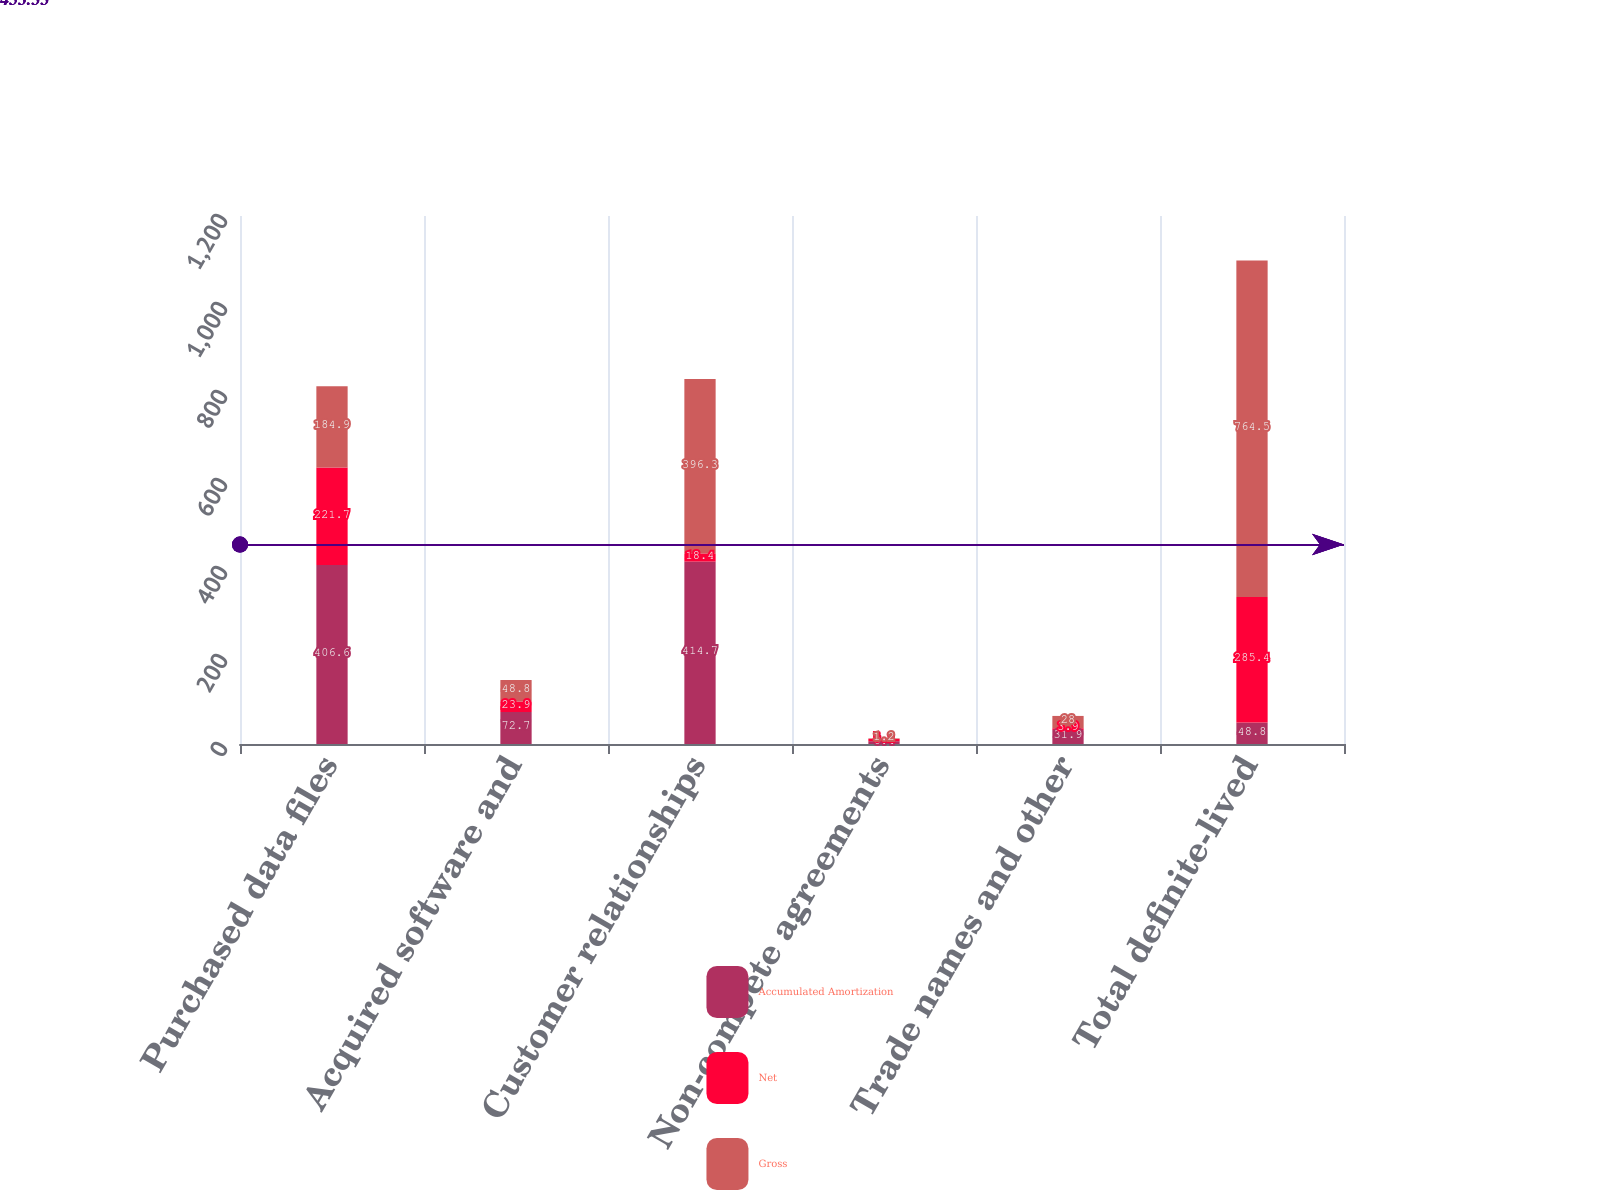Convert chart. <chart><loc_0><loc_0><loc_500><loc_500><stacked_bar_chart><ecel><fcel>Purchased data files<fcel>Acquired software and<fcel>Customer relationships<fcel>Non-compete agreements<fcel>Trade names and other<fcel>Total definite-lived<nl><fcel>Accumulated Amortization<fcel>406.6<fcel>72.7<fcel>414.7<fcel>6.4<fcel>31.9<fcel>48.8<nl><fcel>Net<fcel>221.7<fcel>23.9<fcel>18.4<fcel>5.2<fcel>3.9<fcel>285.4<nl><fcel>Gross<fcel>184.9<fcel>48.8<fcel>396.3<fcel>1.2<fcel>28<fcel>764.5<nl></chart> 